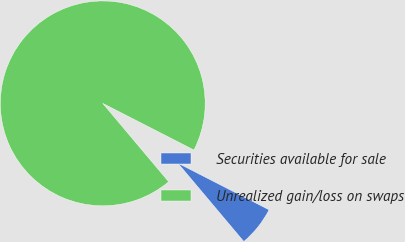Convert chart. <chart><loc_0><loc_0><loc_500><loc_500><pie_chart><fcel>Securities available for sale<fcel>Unrealized gain/loss on swaps<nl><fcel>6.34%<fcel>93.66%<nl></chart> 